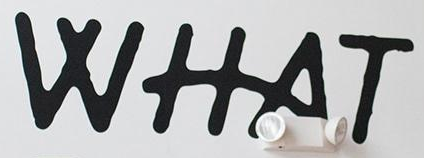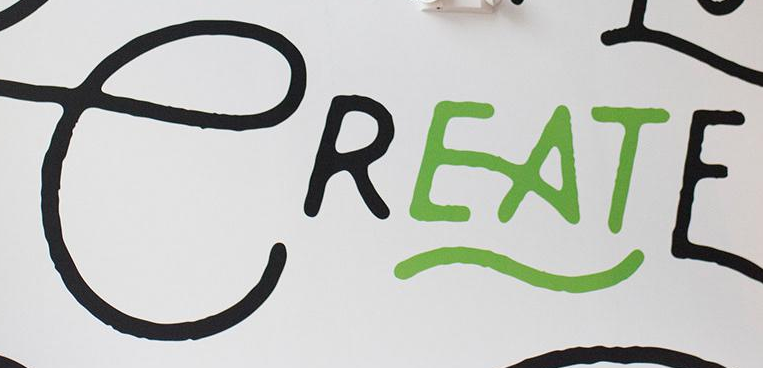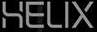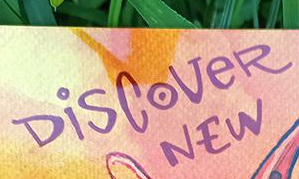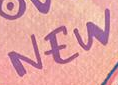Read the text content from these images in order, separated by a semicolon. WHAT; CREATE; HELIX; DiSCoVeR; NEW 